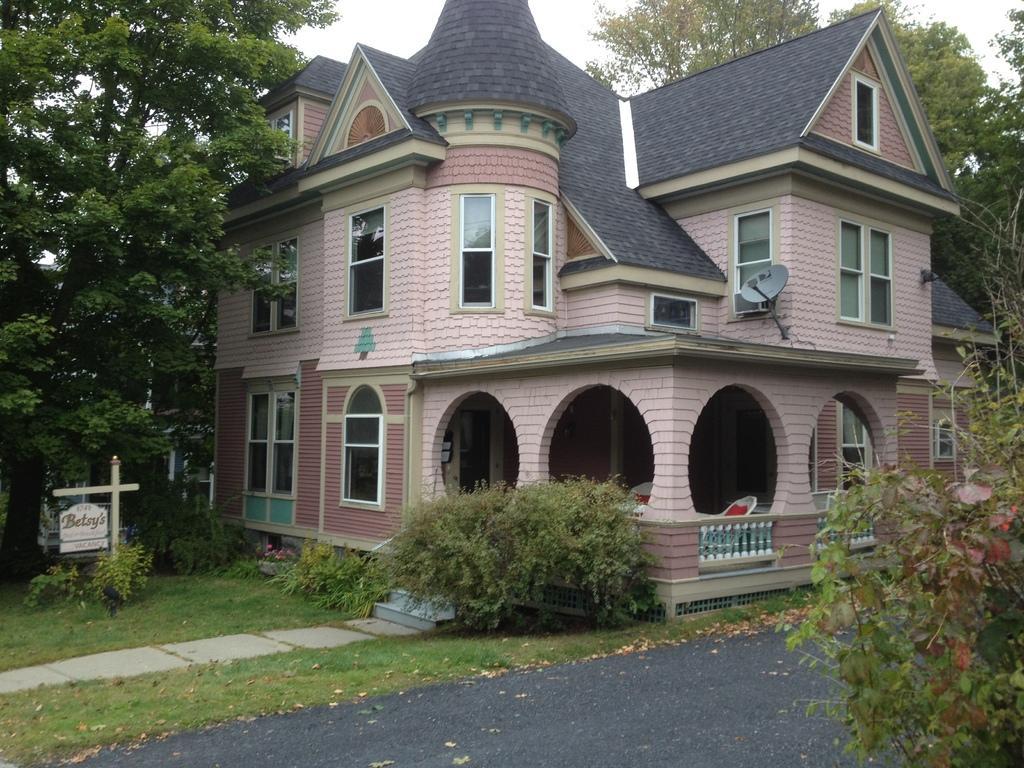Describe this image in one or two sentences. In the image we can see a building and the windows of the building. There are stairs, fence, pole and a board. Here we can see a road, grass, plant, trees and a white sky. 